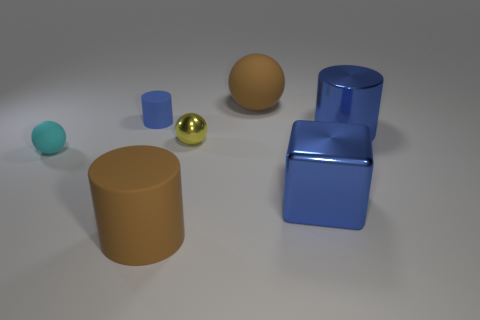What size is the cylinder that is both on the left side of the brown sphere and in front of the tiny cylinder?
Keep it short and to the point. Large. There is a cyan matte object that is the same size as the yellow thing; what shape is it?
Give a very brief answer. Sphere. Are there any big brown matte cylinders that are behind the tiny ball that is on the left side of the small blue cylinder?
Your answer should be very brief. No. There is another big matte thing that is the same shape as the blue rubber object; what color is it?
Provide a short and direct response. Brown. There is a cylinder in front of the metallic cylinder; is it the same color as the small matte cylinder?
Make the answer very short. No. What number of objects are either big metal things behind the large blue block or big brown rubber balls?
Your answer should be very brief. 2. What material is the blue thing on the left side of the big thing that is behind the blue metal object right of the large blue shiny cube?
Offer a terse response. Rubber. Are there more big brown objects that are in front of the large shiny block than large brown rubber objects in front of the small yellow ball?
Give a very brief answer. No. What number of spheres are cyan matte things or large brown objects?
Provide a short and direct response. 2. What number of small cyan rubber balls are on the left side of the brown object behind the blue cylinder that is right of the large metallic cube?
Offer a very short reply. 1. 